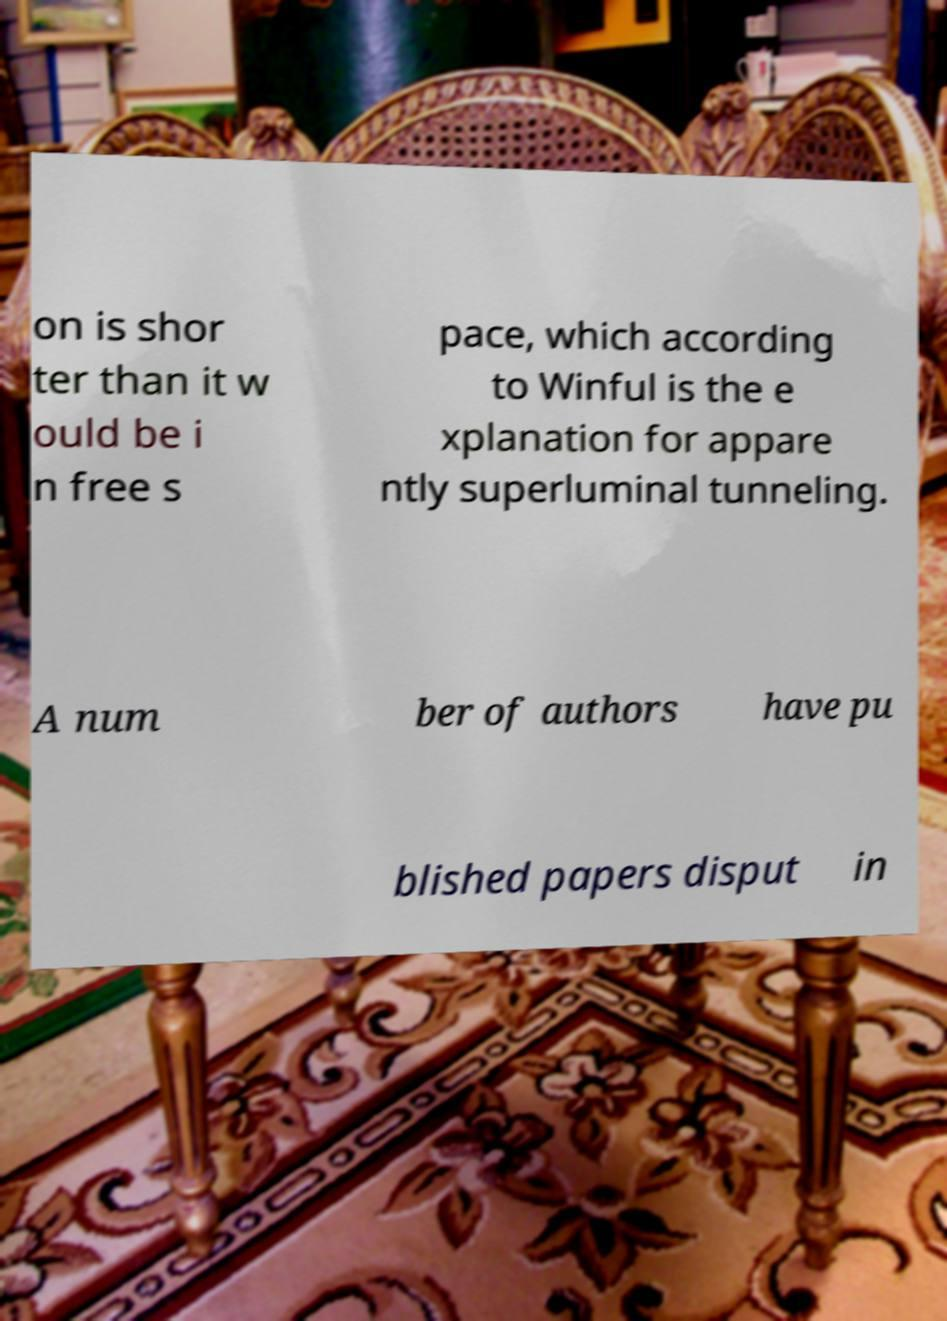Could you assist in decoding the text presented in this image and type it out clearly? on is shor ter than it w ould be i n free s pace, which according to Winful is the e xplanation for appare ntly superluminal tunneling. A num ber of authors have pu blished papers disput in 